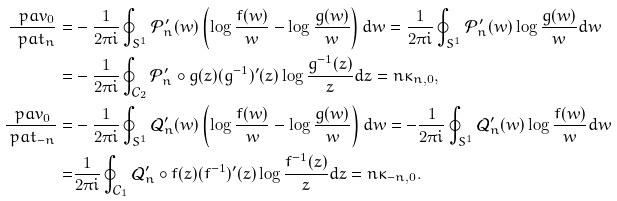<formula> <loc_0><loc_0><loc_500><loc_500>\frac { \ p a v _ { 0 } } { \ p a t _ { n } } = & - \frac { 1 } { 2 \pi i } \oint _ { S ^ { 1 } } \mathcal { P } _ { n } ^ { \prime } ( w ) \left ( \log \frac { f ( w ) } { w } - \log \frac { g ( w ) } { w } \right ) d w = \frac { 1 } { 2 \pi i } \oint _ { S ^ { 1 } } \mathcal { P } _ { n } ^ { \prime } ( w ) \log \frac { g ( w ) } { w } d w \\ = & - \frac { 1 } { 2 \pi i } \oint _ { \mathcal { C } _ { 2 } } \mathcal { P } _ { n } ^ { \prime } \circ g ( z ) ( g ^ { - 1 } ) ^ { \prime } ( z ) \log \frac { g ^ { - 1 } ( z ) } { z } d z = n \kappa _ { n , 0 } , \\ \frac { \ p a v _ { 0 } } { \ p a t _ { - n } } = & - \frac { 1 } { 2 \pi i } \oint _ { S ^ { 1 } } \mathcal { Q } _ { n } ^ { \prime } ( w ) \left ( \log \frac { f ( w ) } { w } - \log \frac { g ( w ) } { w } \right ) d w = - \frac { 1 } { 2 \pi i } \oint _ { S ^ { 1 } } \mathcal { Q } _ { n } ^ { \prime } ( w ) \log \frac { f ( w ) } { w } d w \\ = & \frac { 1 } { 2 \pi i } \oint _ { \mathcal { C } _ { 1 } } \mathcal { Q } _ { n } ^ { \prime } \circ f ( z ) ( f ^ { - 1 } ) ^ { \prime } ( z ) \log \frac { f ^ { - 1 } ( z ) } { z } d z = n \kappa _ { - n , 0 } . \\</formula> 